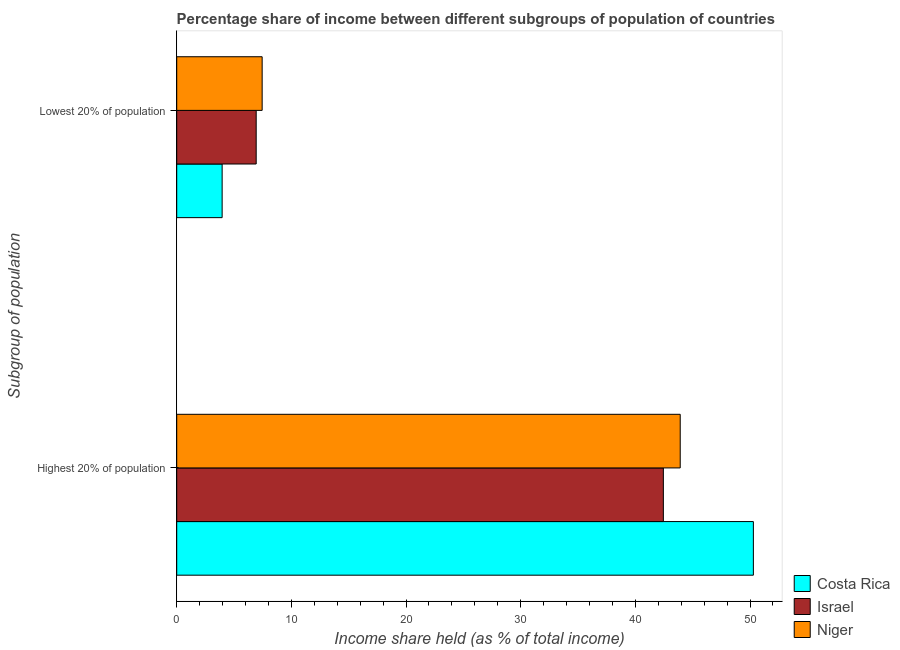How many different coloured bars are there?
Make the answer very short. 3. How many groups of bars are there?
Ensure brevity in your answer.  2. Are the number of bars on each tick of the Y-axis equal?
Ensure brevity in your answer.  Yes. How many bars are there on the 1st tick from the bottom?
Give a very brief answer. 3. What is the label of the 2nd group of bars from the top?
Give a very brief answer. Highest 20% of population. What is the income share held by highest 20% of the population in Israel?
Make the answer very short. 42.44. Across all countries, what is the maximum income share held by highest 20% of the population?
Ensure brevity in your answer.  50.29. Across all countries, what is the minimum income share held by lowest 20% of the population?
Your answer should be compact. 3.96. In which country was the income share held by lowest 20% of the population maximum?
Offer a terse response. Niger. In which country was the income share held by lowest 20% of the population minimum?
Keep it short and to the point. Costa Rica. What is the total income share held by highest 20% of the population in the graph?
Your answer should be very brief. 136.64. What is the difference between the income share held by lowest 20% of the population in Costa Rica and that in Israel?
Keep it short and to the point. -2.97. What is the difference between the income share held by highest 20% of the population in Costa Rica and the income share held by lowest 20% of the population in Niger?
Make the answer very short. 42.84. What is the average income share held by lowest 20% of the population per country?
Your response must be concise. 6.11. What is the difference between the income share held by highest 20% of the population and income share held by lowest 20% of the population in Costa Rica?
Ensure brevity in your answer.  46.33. What is the ratio of the income share held by lowest 20% of the population in Costa Rica to that in Niger?
Ensure brevity in your answer.  0.53. Is the income share held by highest 20% of the population in Niger less than that in Costa Rica?
Ensure brevity in your answer.  Yes. What does the 1st bar from the top in Lowest 20% of population represents?
Ensure brevity in your answer.  Niger. What does the 2nd bar from the bottom in Lowest 20% of population represents?
Make the answer very short. Israel. How many bars are there?
Offer a terse response. 6. How many countries are there in the graph?
Ensure brevity in your answer.  3. What is the difference between two consecutive major ticks on the X-axis?
Your answer should be compact. 10. Where does the legend appear in the graph?
Ensure brevity in your answer.  Bottom right. How many legend labels are there?
Offer a very short reply. 3. How are the legend labels stacked?
Keep it short and to the point. Vertical. What is the title of the graph?
Offer a very short reply. Percentage share of income between different subgroups of population of countries. Does "Pacific island small states" appear as one of the legend labels in the graph?
Keep it short and to the point. No. What is the label or title of the X-axis?
Your answer should be very brief. Income share held (as % of total income). What is the label or title of the Y-axis?
Give a very brief answer. Subgroup of population. What is the Income share held (as % of total income) in Costa Rica in Highest 20% of population?
Your response must be concise. 50.29. What is the Income share held (as % of total income) of Israel in Highest 20% of population?
Keep it short and to the point. 42.44. What is the Income share held (as % of total income) in Niger in Highest 20% of population?
Provide a short and direct response. 43.91. What is the Income share held (as % of total income) of Costa Rica in Lowest 20% of population?
Give a very brief answer. 3.96. What is the Income share held (as % of total income) of Israel in Lowest 20% of population?
Offer a terse response. 6.93. What is the Income share held (as % of total income) in Niger in Lowest 20% of population?
Your answer should be very brief. 7.45. Across all Subgroup of population, what is the maximum Income share held (as % of total income) of Costa Rica?
Make the answer very short. 50.29. Across all Subgroup of population, what is the maximum Income share held (as % of total income) of Israel?
Ensure brevity in your answer.  42.44. Across all Subgroup of population, what is the maximum Income share held (as % of total income) of Niger?
Provide a succinct answer. 43.91. Across all Subgroup of population, what is the minimum Income share held (as % of total income) of Costa Rica?
Offer a very short reply. 3.96. Across all Subgroup of population, what is the minimum Income share held (as % of total income) of Israel?
Offer a terse response. 6.93. Across all Subgroup of population, what is the minimum Income share held (as % of total income) of Niger?
Your response must be concise. 7.45. What is the total Income share held (as % of total income) of Costa Rica in the graph?
Your answer should be very brief. 54.25. What is the total Income share held (as % of total income) of Israel in the graph?
Offer a terse response. 49.37. What is the total Income share held (as % of total income) of Niger in the graph?
Ensure brevity in your answer.  51.36. What is the difference between the Income share held (as % of total income) of Costa Rica in Highest 20% of population and that in Lowest 20% of population?
Offer a terse response. 46.33. What is the difference between the Income share held (as % of total income) in Israel in Highest 20% of population and that in Lowest 20% of population?
Keep it short and to the point. 35.51. What is the difference between the Income share held (as % of total income) of Niger in Highest 20% of population and that in Lowest 20% of population?
Ensure brevity in your answer.  36.46. What is the difference between the Income share held (as % of total income) in Costa Rica in Highest 20% of population and the Income share held (as % of total income) in Israel in Lowest 20% of population?
Provide a short and direct response. 43.36. What is the difference between the Income share held (as % of total income) in Costa Rica in Highest 20% of population and the Income share held (as % of total income) in Niger in Lowest 20% of population?
Your answer should be very brief. 42.84. What is the difference between the Income share held (as % of total income) of Israel in Highest 20% of population and the Income share held (as % of total income) of Niger in Lowest 20% of population?
Keep it short and to the point. 34.99. What is the average Income share held (as % of total income) in Costa Rica per Subgroup of population?
Your response must be concise. 27.12. What is the average Income share held (as % of total income) in Israel per Subgroup of population?
Provide a succinct answer. 24.68. What is the average Income share held (as % of total income) of Niger per Subgroup of population?
Provide a succinct answer. 25.68. What is the difference between the Income share held (as % of total income) in Costa Rica and Income share held (as % of total income) in Israel in Highest 20% of population?
Offer a terse response. 7.85. What is the difference between the Income share held (as % of total income) in Costa Rica and Income share held (as % of total income) in Niger in Highest 20% of population?
Offer a very short reply. 6.38. What is the difference between the Income share held (as % of total income) of Israel and Income share held (as % of total income) of Niger in Highest 20% of population?
Your answer should be very brief. -1.47. What is the difference between the Income share held (as % of total income) in Costa Rica and Income share held (as % of total income) in Israel in Lowest 20% of population?
Keep it short and to the point. -2.97. What is the difference between the Income share held (as % of total income) of Costa Rica and Income share held (as % of total income) of Niger in Lowest 20% of population?
Provide a succinct answer. -3.49. What is the difference between the Income share held (as % of total income) in Israel and Income share held (as % of total income) in Niger in Lowest 20% of population?
Your response must be concise. -0.52. What is the ratio of the Income share held (as % of total income) of Costa Rica in Highest 20% of population to that in Lowest 20% of population?
Ensure brevity in your answer.  12.7. What is the ratio of the Income share held (as % of total income) of Israel in Highest 20% of population to that in Lowest 20% of population?
Offer a very short reply. 6.12. What is the ratio of the Income share held (as % of total income) in Niger in Highest 20% of population to that in Lowest 20% of population?
Provide a succinct answer. 5.89. What is the difference between the highest and the second highest Income share held (as % of total income) in Costa Rica?
Give a very brief answer. 46.33. What is the difference between the highest and the second highest Income share held (as % of total income) of Israel?
Offer a very short reply. 35.51. What is the difference between the highest and the second highest Income share held (as % of total income) of Niger?
Provide a succinct answer. 36.46. What is the difference between the highest and the lowest Income share held (as % of total income) in Costa Rica?
Make the answer very short. 46.33. What is the difference between the highest and the lowest Income share held (as % of total income) of Israel?
Your answer should be compact. 35.51. What is the difference between the highest and the lowest Income share held (as % of total income) of Niger?
Offer a terse response. 36.46. 